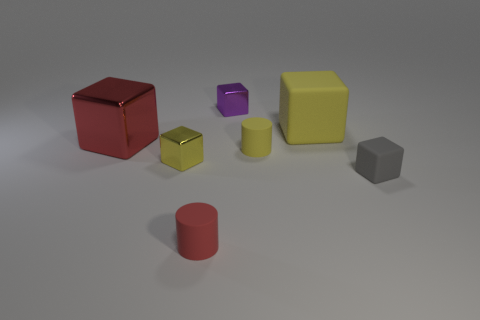If you had to estimate, what time of day does this lighting remind you of? Could these be indoor or outdoor objects? While this image is likely a controlled studio setup, the lighting has a natural quality that might be reminiscent of late afternoon light. However, considering the lack of environmental context, these could just as well be indoor objects illuminated with artificial lighting designed to mimic daylight. 